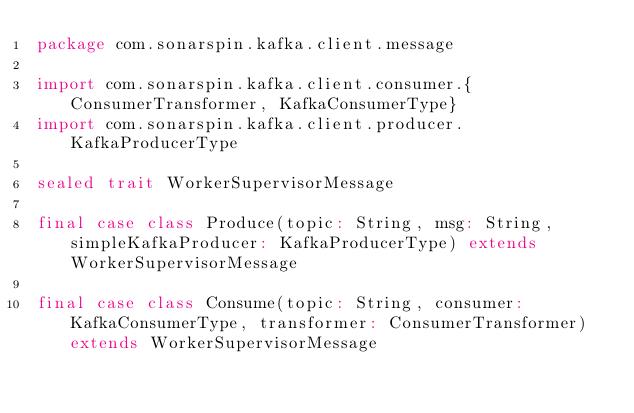<code> <loc_0><loc_0><loc_500><loc_500><_Scala_>package com.sonarspin.kafka.client.message

import com.sonarspin.kafka.client.consumer.{ConsumerTransformer, KafkaConsumerType}
import com.sonarspin.kafka.client.producer.KafkaProducerType

sealed trait WorkerSupervisorMessage

final case class Produce(topic: String, msg: String, simpleKafkaProducer: KafkaProducerType) extends WorkerSupervisorMessage

final case class Consume(topic: String, consumer: KafkaConsumerType, transformer: ConsumerTransformer) extends WorkerSupervisorMessage
</code> 